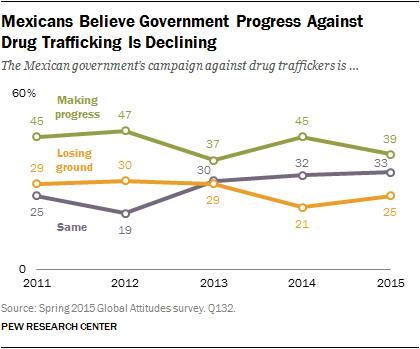Identify some key points in this picture. The Mexican government's campaign against drug traffickers, which began in 2012, has made a progress of 47 percent. In 2011, the sum of making progress, losing ground, and staying the same was 99. 